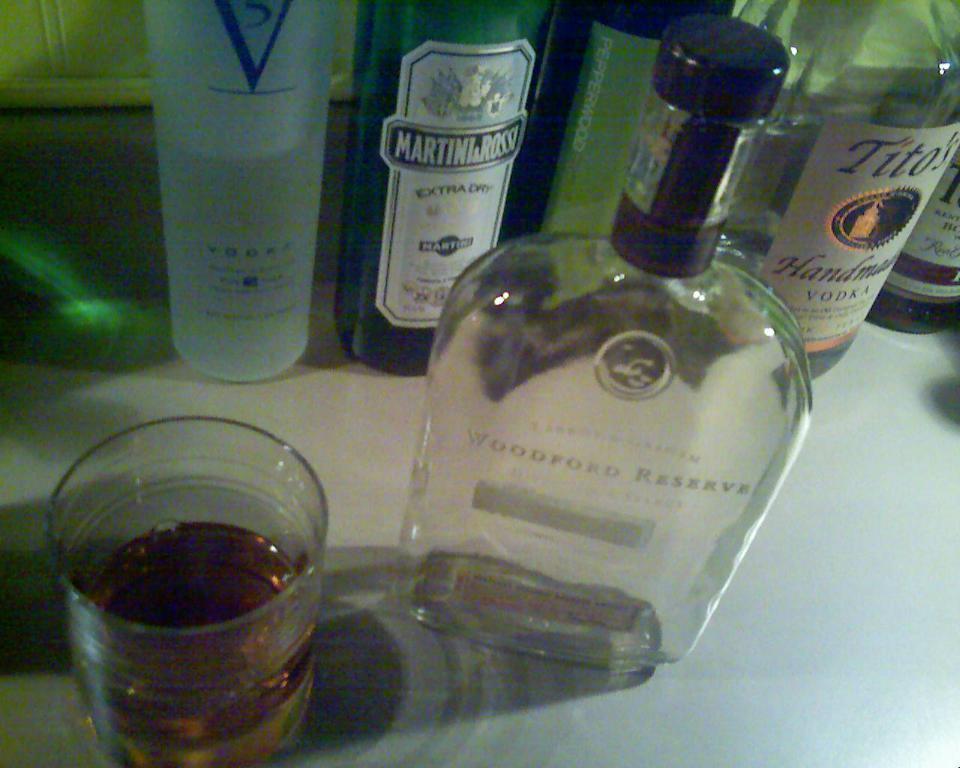What brand of vodka is in the top right?
Provide a short and direct response. Tito's. 